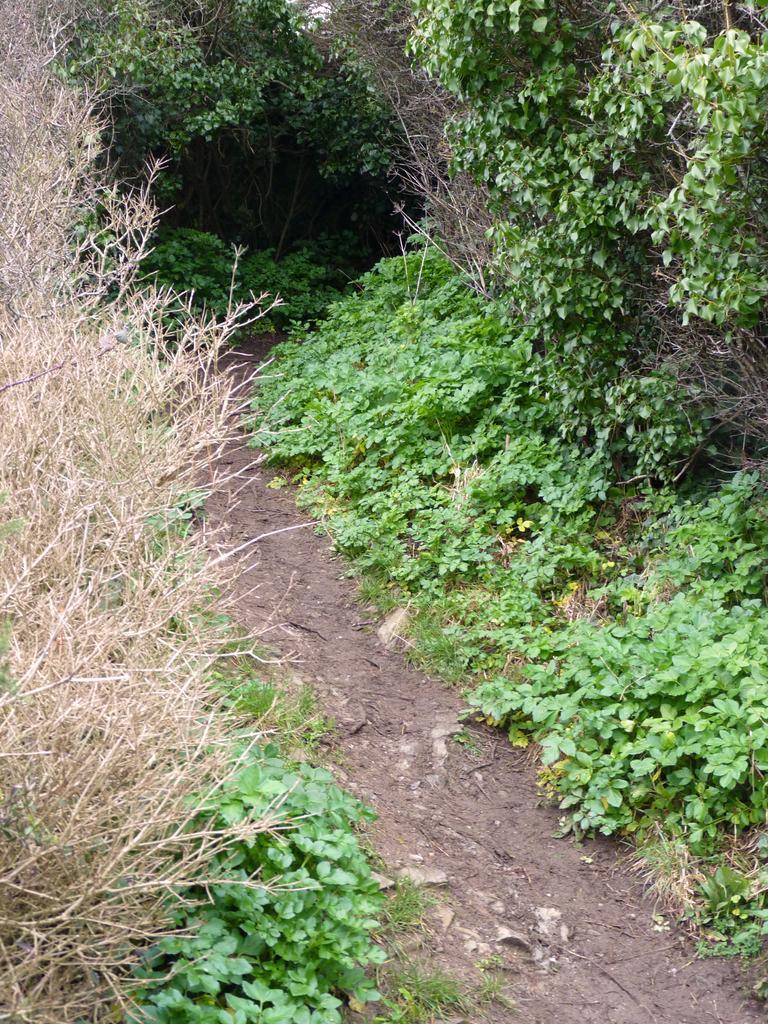In one or two sentences, can you explain what this image depicts? This is a picture taken in a small street. On the left there are shrubs, plants and trees. On the right there are shrubs and trees. In the center there is a path. 